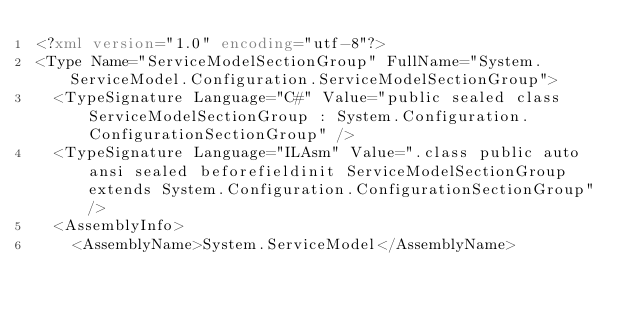Convert code to text. <code><loc_0><loc_0><loc_500><loc_500><_XML_><?xml version="1.0" encoding="utf-8"?>
<Type Name="ServiceModelSectionGroup" FullName="System.ServiceModel.Configuration.ServiceModelSectionGroup">
  <TypeSignature Language="C#" Value="public sealed class ServiceModelSectionGroup : System.Configuration.ConfigurationSectionGroup" />
  <TypeSignature Language="ILAsm" Value=".class public auto ansi sealed beforefieldinit ServiceModelSectionGroup extends System.Configuration.ConfigurationSectionGroup" />
  <AssemblyInfo>
    <AssemblyName>System.ServiceModel</AssemblyName></code> 